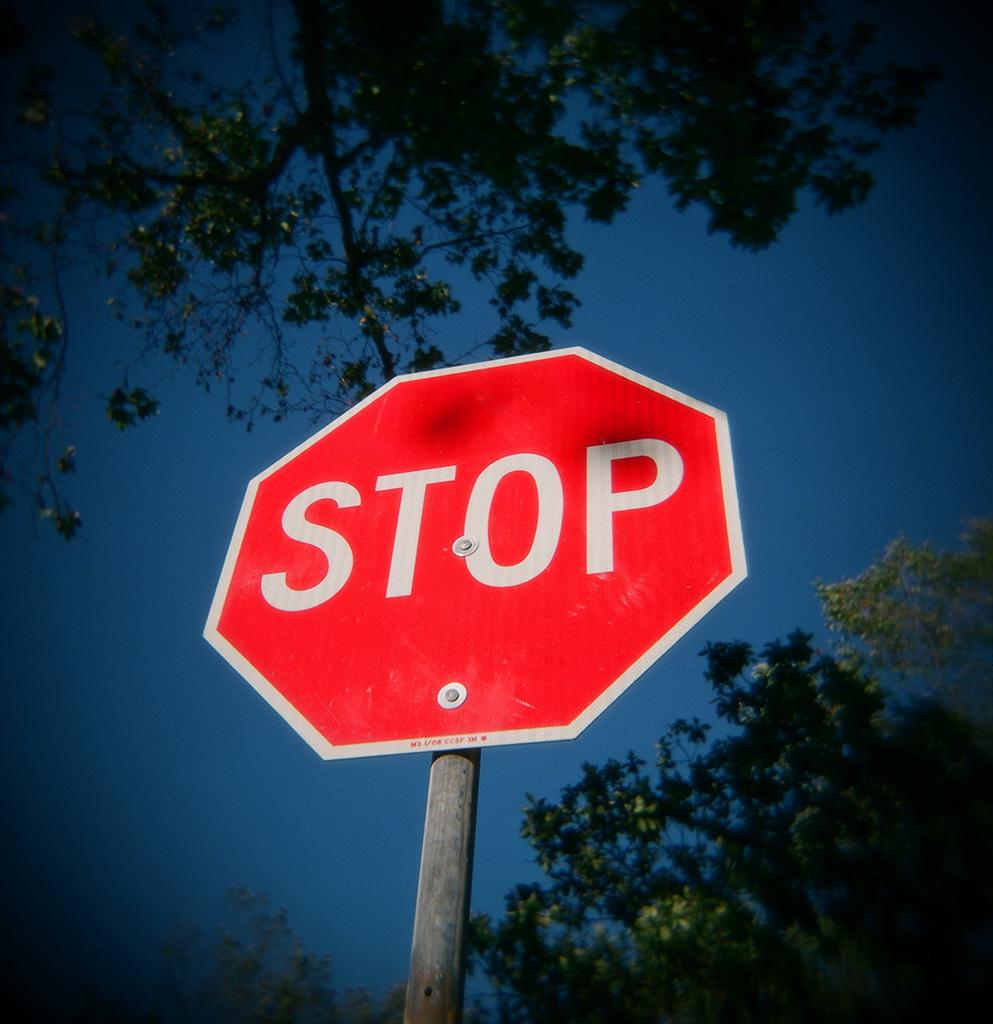Provide a one-sentence caption for the provided image. A STOP sign is placed on a street with sky and tree branches above it. 